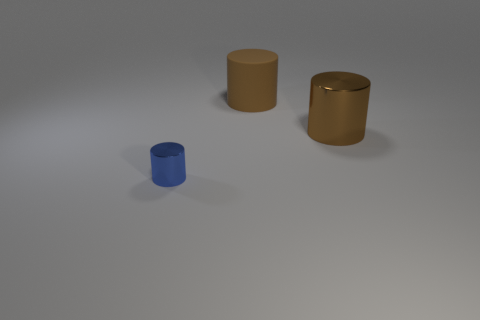Add 1 large brown shiny spheres. How many objects exist? 4 Subtract all brown cylinders. How many cylinders are left? 1 Subtract all brown cylinders. How many cylinders are left? 1 Subtract 0 green spheres. How many objects are left? 3 Subtract all brown cylinders. Subtract all red spheres. How many cylinders are left? 1 Subtract all brown cubes. How many blue cylinders are left? 1 Subtract all big brown rubber objects. Subtract all large brown objects. How many objects are left? 0 Add 3 rubber cylinders. How many rubber cylinders are left? 4 Add 1 tiny blue metallic objects. How many tiny blue metallic objects exist? 2 